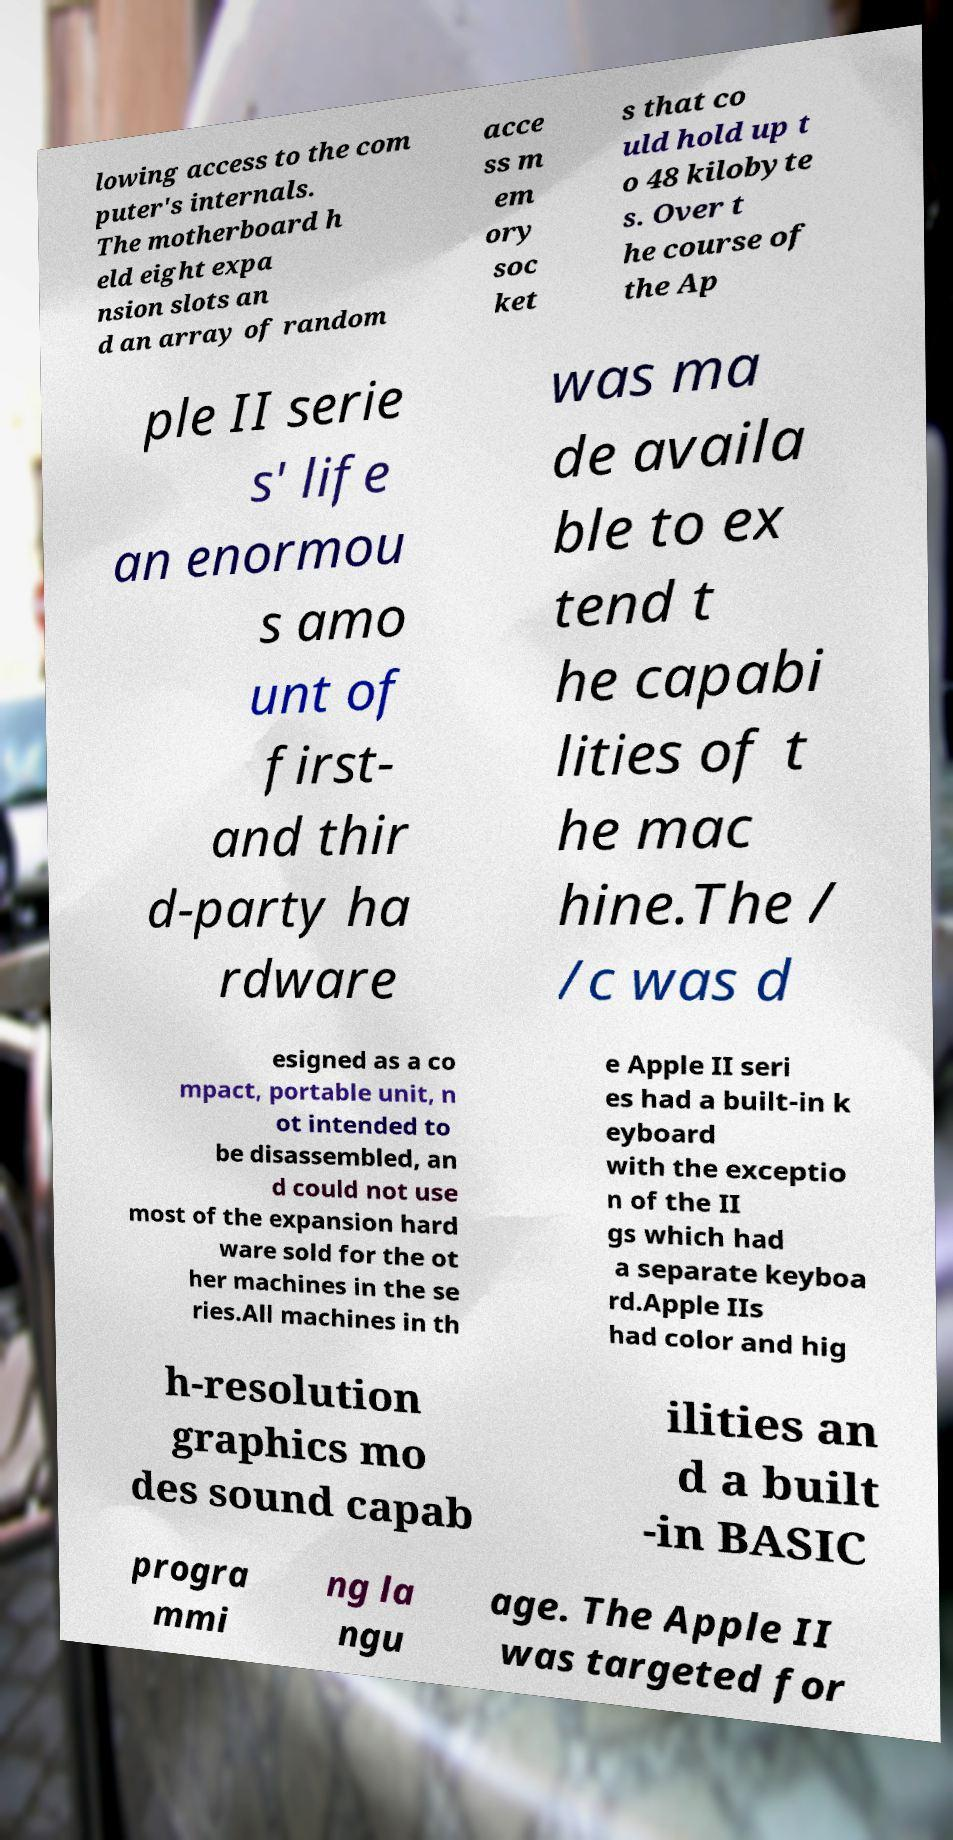There's text embedded in this image that I need extracted. Can you transcribe it verbatim? lowing access to the com puter's internals. The motherboard h eld eight expa nsion slots an d an array of random acce ss m em ory soc ket s that co uld hold up t o 48 kilobyte s. Over t he course of the Ap ple II serie s' life an enormou s amo unt of first- and thir d-party ha rdware was ma de availa ble to ex tend t he capabi lities of t he mac hine.The / /c was d esigned as a co mpact, portable unit, n ot intended to be disassembled, an d could not use most of the expansion hard ware sold for the ot her machines in the se ries.All machines in th e Apple II seri es had a built-in k eyboard with the exceptio n of the II gs which had a separate keyboa rd.Apple IIs had color and hig h-resolution graphics mo des sound capab ilities an d a built -in BASIC progra mmi ng la ngu age. The Apple II was targeted for 